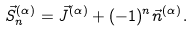Convert formula to latex. <formula><loc_0><loc_0><loc_500><loc_500>\vec { S } ^ { ( \alpha ) } _ { n } = \vec { J } ^ { ( \alpha ) } + ( - 1 ) ^ { n } \vec { n } ^ { ( \alpha ) } .</formula> 